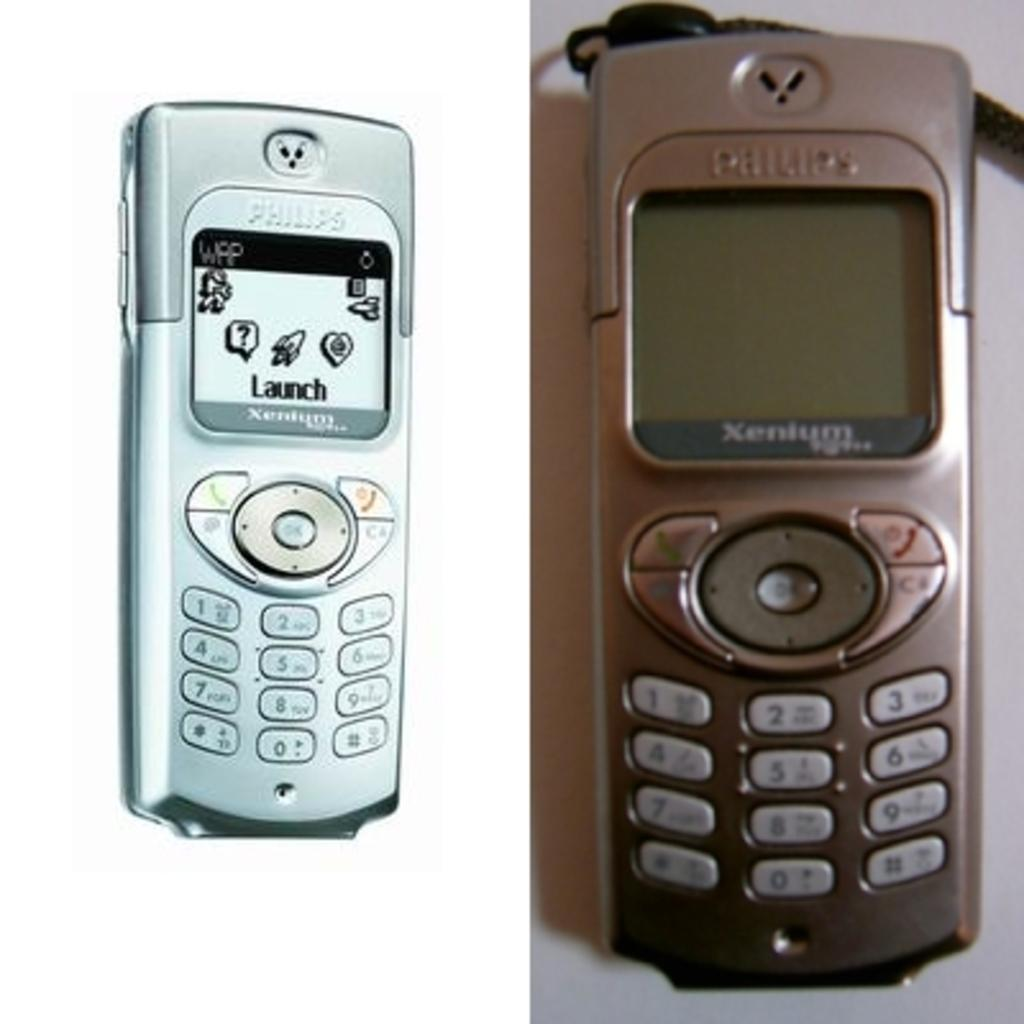<image>
Share a concise interpretation of the image provided. Two Nokia Xenium phones, one silver the other brown are seen close up. The brown phone ios off the silver one has old style app icons on its screen. 